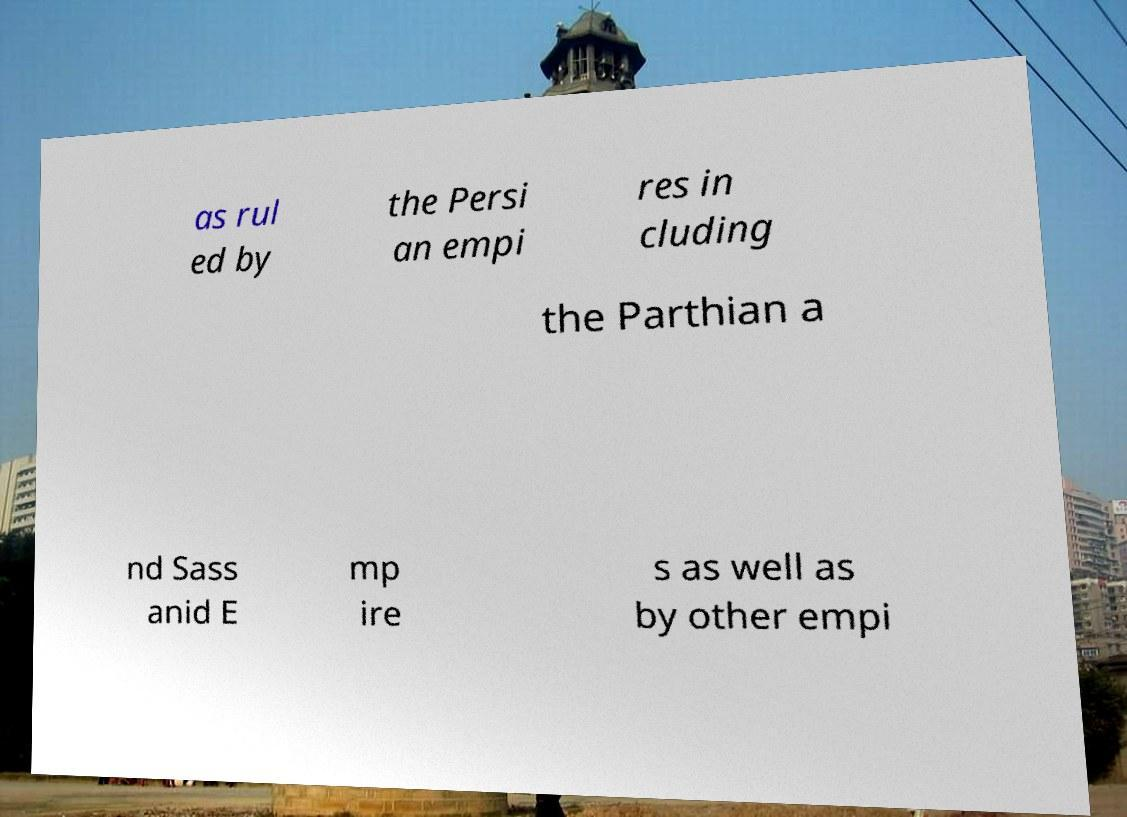Can you accurately transcribe the text from the provided image for me? as rul ed by the Persi an empi res in cluding the Parthian a nd Sass anid E mp ire s as well as by other empi 